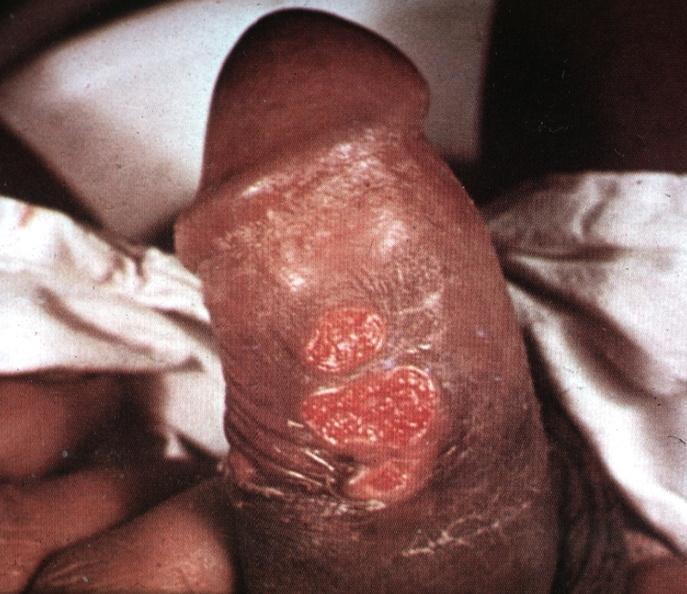what is present?
Answer the question using a single word or phrase. Penis 